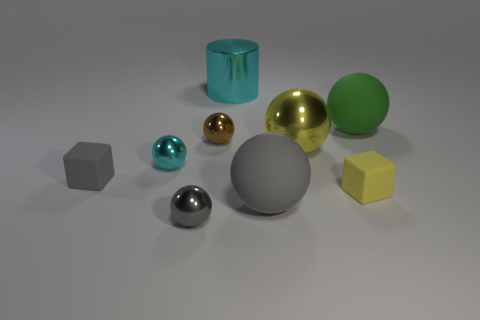What materials do the objects in the image appear to be made of? The objects in the image seem to be made of various materials, including shiny metals for the spheres and cylinders, and a more matte, possibly plastic material for the hexahedrons. 